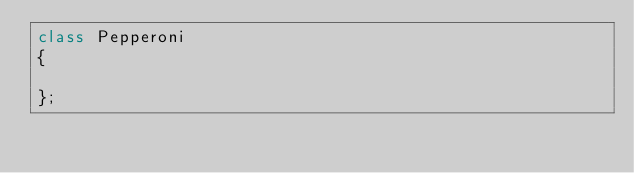<code> <loc_0><loc_0><loc_500><loc_500><_C++_>class Pepperoni
{

};</code> 